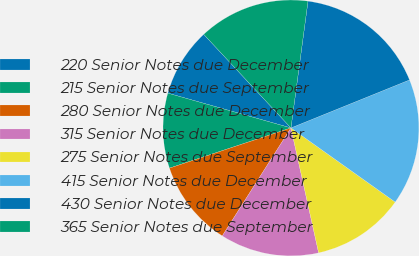<chart> <loc_0><loc_0><loc_500><loc_500><pie_chart><fcel>220 Senior Notes due December<fcel>215 Senior Notes due September<fcel>280 Senior Notes due December<fcel>315 Senior Notes due December<fcel>275 Senior Notes due September<fcel>415 Senior Notes due December<fcel>430 Senior Notes due December<fcel>365 Senior Notes due September<nl><fcel>8.68%<fcel>9.47%<fcel>10.9%<fcel>12.49%<fcel>11.69%<fcel>15.96%<fcel>16.75%<fcel>14.07%<nl></chart> 